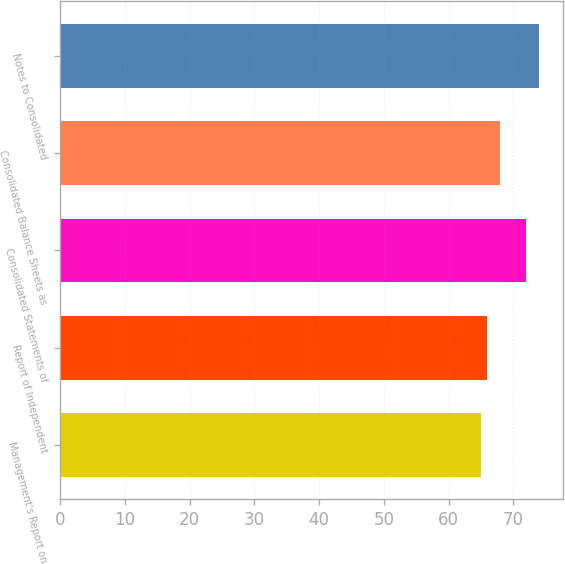<chart> <loc_0><loc_0><loc_500><loc_500><bar_chart><fcel>Management's Report on<fcel>Report of Independent<fcel>Consolidated Statements of<fcel>Consolidated Balance Sheets as<fcel>Notes to Consolidated<nl><fcel>65<fcel>66<fcel>72<fcel>68<fcel>74<nl></chart> 